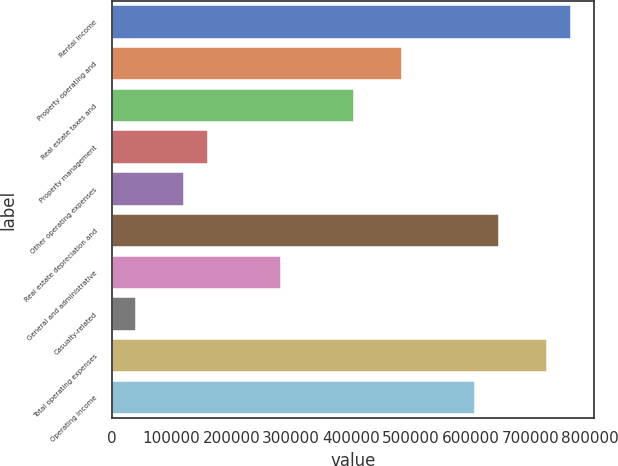<chart> <loc_0><loc_0><loc_500><loc_500><bar_chart><fcel>Rental income<fcel>Property operating and<fcel>Real estate taxes and<fcel>Property management<fcel>Other operating expenses<fcel>Real estate depreciation and<fcel>General and administrative<fcel>Casualty-related<fcel>Total operating expenses<fcel>Operating income<nl><fcel>768388<fcel>485298<fcel>404415<fcel>161766<fcel>121325<fcel>647064<fcel>283091<fcel>40441.9<fcel>727947<fcel>606622<nl></chart> 